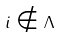Convert formula to latex. <formula><loc_0><loc_0><loc_500><loc_500>i \notin \Lambda</formula> 